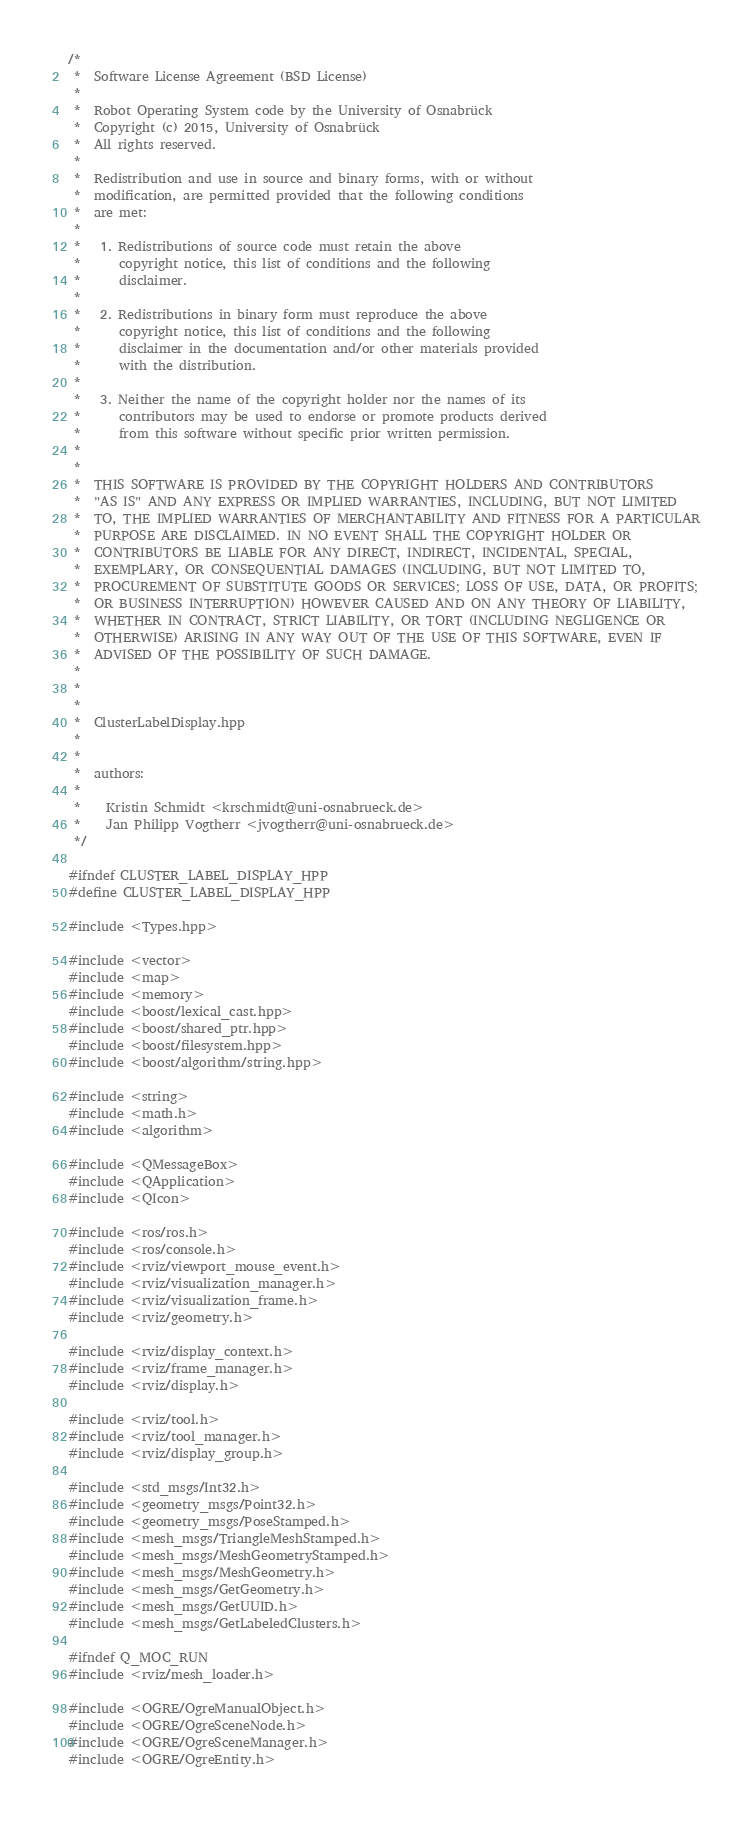<code> <loc_0><loc_0><loc_500><loc_500><_C++_>/*
 *  Software License Agreement (BSD License)
 *
 *  Robot Operating System code by the University of Osnabrück
 *  Copyright (c) 2015, University of Osnabrück
 *  All rights reserved.
 *
 *  Redistribution and use in source and binary forms, with or without
 *  modification, are permitted provided that the following conditions
 *  are met:
 *
 *   1. Redistributions of source code must retain the above
 *      copyright notice, this list of conditions and the following
 *      disclaimer.
 *
 *   2. Redistributions in binary form must reproduce the above
 *      copyright notice, this list of conditions and the following
 *      disclaimer in the documentation and/or other materials provided
 *      with the distribution.
 *
 *   3. Neither the name of the copyright holder nor the names of its
 *      contributors may be used to endorse or promote products derived
 *      from this software without specific prior written permission.
 *
 *
 *  THIS SOFTWARE IS PROVIDED BY THE COPYRIGHT HOLDERS AND CONTRIBUTORS
 *  "AS IS" AND ANY EXPRESS OR IMPLIED WARRANTIES, INCLUDING, BUT NOT LIMITED
 *  TO, THE IMPLIED WARRANTIES OF MERCHANTABILITY AND FITNESS FOR A PARTICULAR
 *  PURPOSE ARE DISCLAIMED. IN NO EVENT SHALL THE COPYRIGHT HOLDER OR
 *  CONTRIBUTORS BE LIABLE FOR ANY DIRECT, INDIRECT, INCIDENTAL, SPECIAL,
 *  EXEMPLARY, OR CONSEQUENTIAL DAMAGES (INCLUDING, BUT NOT LIMITED TO,
 *  PROCUREMENT OF SUBSTITUTE GOODS OR SERVICES; LOSS OF USE, DATA, OR PROFITS;
 *  OR BUSINESS INTERRUPTION) HOWEVER CAUSED AND ON ANY THEORY OF LIABILITY,
 *  WHETHER IN CONTRACT, STRICT LIABILITY, OR TORT (INCLUDING NEGLIGENCE OR
 *  OTHERWISE) ARISING IN ANY WAY OUT OF THE USE OF THIS SOFTWARE, EVEN IF
 *  ADVISED OF THE POSSIBILITY OF SUCH DAMAGE.
 *
 *
 *
 *  ClusterLabelDisplay.hpp
 *
 *
 *  authors:
 *
 *    Kristin Schmidt <krschmidt@uni-osnabrueck.de>
 *    Jan Philipp Vogtherr <jvogtherr@uni-osnabrueck.de>
 */

#ifndef CLUSTER_LABEL_DISPLAY_HPP
#define CLUSTER_LABEL_DISPLAY_HPP

#include <Types.hpp>

#include <vector>
#include <map>
#include <memory>
#include <boost/lexical_cast.hpp>
#include <boost/shared_ptr.hpp>
#include <boost/filesystem.hpp>
#include <boost/algorithm/string.hpp>

#include <string>
#include <math.h>
#include <algorithm>

#include <QMessageBox>
#include <QApplication>
#include <QIcon>

#include <ros/ros.h>
#include <ros/console.h>
#include <rviz/viewport_mouse_event.h>
#include <rviz/visualization_manager.h>
#include <rviz/visualization_frame.h>
#include <rviz/geometry.h>

#include <rviz/display_context.h>
#include <rviz/frame_manager.h>
#include <rviz/display.h>

#include <rviz/tool.h>
#include <rviz/tool_manager.h>
#include <rviz/display_group.h>

#include <std_msgs/Int32.h>
#include <geometry_msgs/Point32.h>
#include <geometry_msgs/PoseStamped.h>
#include <mesh_msgs/TriangleMeshStamped.h>
#include <mesh_msgs/MeshGeometryStamped.h>
#include <mesh_msgs/MeshGeometry.h>
#include <mesh_msgs/GetGeometry.h>
#include <mesh_msgs/GetUUID.h>
#include <mesh_msgs/GetLabeledClusters.h>

#ifndef Q_MOC_RUN
#include <rviz/mesh_loader.h>

#include <OGRE/OgreManualObject.h>
#include <OGRE/OgreSceneNode.h>
#include <OGRE/OgreSceneManager.h>
#include <OGRE/OgreEntity.h></code> 